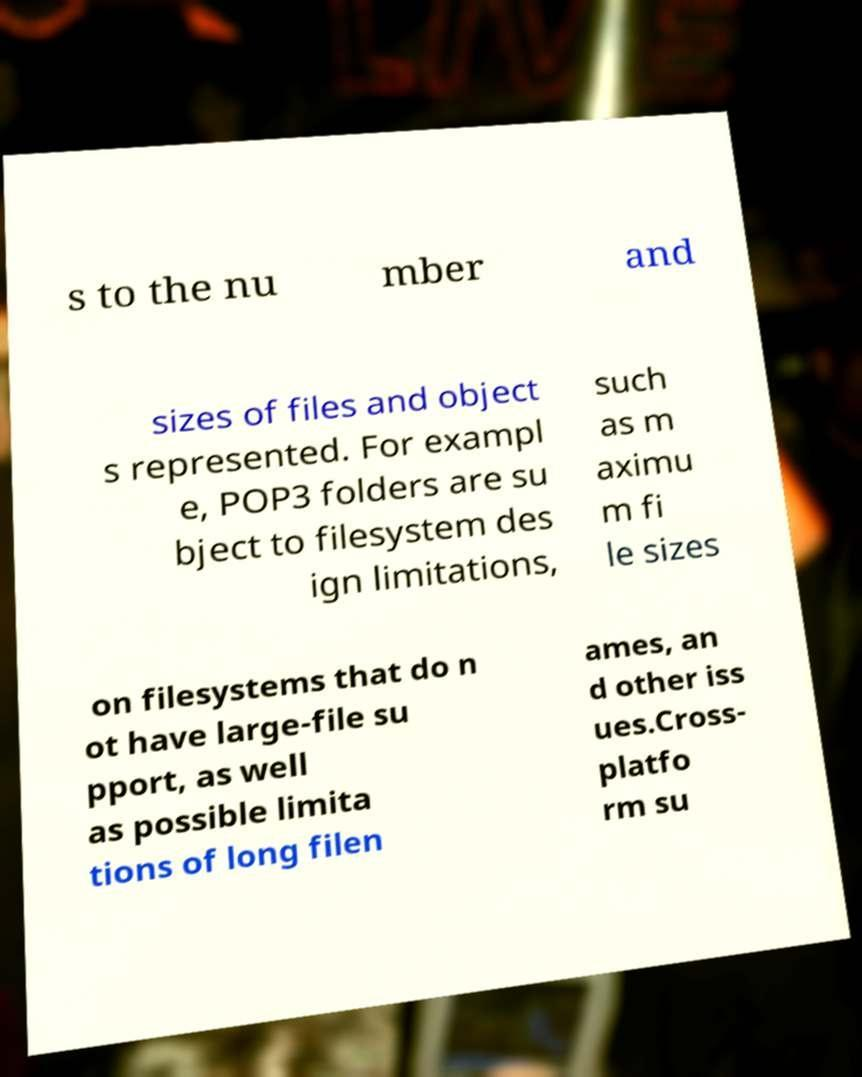What messages or text are displayed in this image? I need them in a readable, typed format. s to the nu mber and sizes of files and object s represented. For exampl e, POP3 folders are su bject to filesystem des ign limitations, such as m aximu m fi le sizes on filesystems that do n ot have large-file su pport, as well as possible limita tions of long filen ames, an d other iss ues.Cross- platfo rm su 